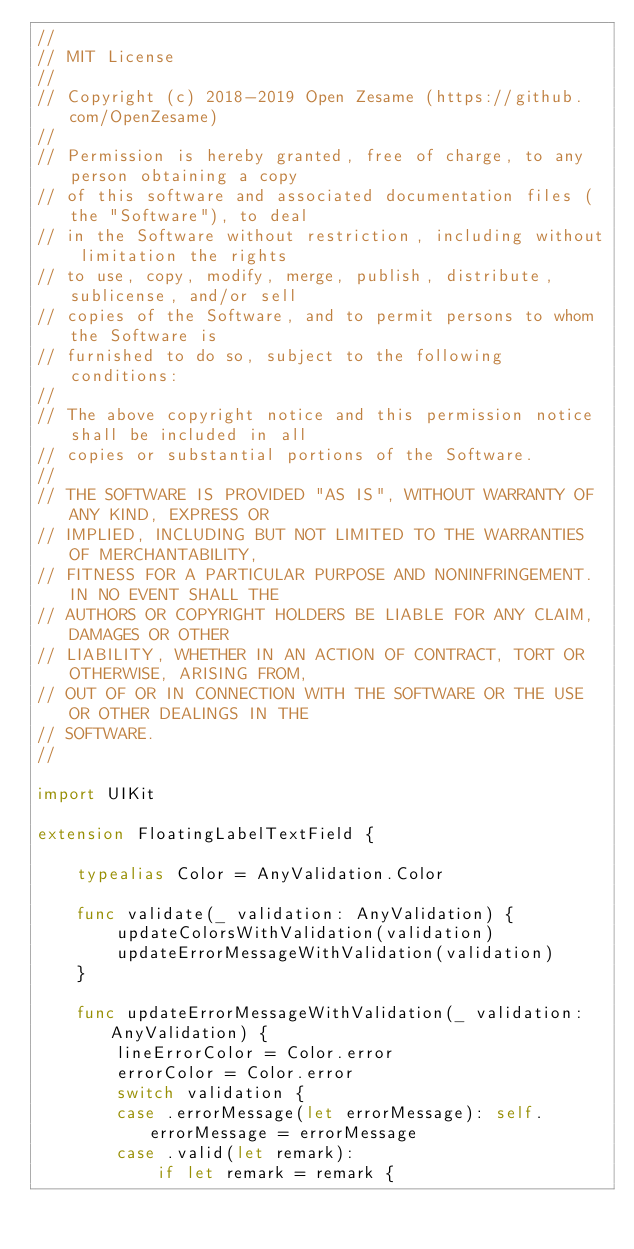<code> <loc_0><loc_0><loc_500><loc_500><_Swift_>// 
// MIT License
//
// Copyright (c) 2018-2019 Open Zesame (https://github.com/OpenZesame)
// 
// Permission is hereby granted, free of charge, to any person obtaining a copy
// of this software and associated documentation files (the "Software"), to deal
// in the Software without restriction, including without limitation the rights
// to use, copy, modify, merge, publish, distribute, sublicense, and/or sell
// copies of the Software, and to permit persons to whom the Software is
// furnished to do so, subject to the following conditions:
// 
// The above copyright notice and this permission notice shall be included in all
// copies or substantial portions of the Software.
// 
// THE SOFTWARE IS PROVIDED "AS IS", WITHOUT WARRANTY OF ANY KIND, EXPRESS OR
// IMPLIED, INCLUDING BUT NOT LIMITED TO THE WARRANTIES OF MERCHANTABILITY,
// FITNESS FOR A PARTICULAR PURPOSE AND NONINFRINGEMENT. IN NO EVENT SHALL THE
// AUTHORS OR COPYRIGHT HOLDERS BE LIABLE FOR ANY CLAIM, DAMAGES OR OTHER
// LIABILITY, WHETHER IN AN ACTION OF CONTRACT, TORT OR OTHERWISE, ARISING FROM,
// OUT OF OR IN CONNECTION WITH THE SOFTWARE OR THE USE OR OTHER DEALINGS IN THE
// SOFTWARE.
//

import UIKit

extension FloatingLabelTextField {
    
    typealias Color = AnyValidation.Color

    func validate(_ validation: AnyValidation) {
        updateColorsWithValidation(validation)
        updateErrorMessageWithValidation(validation)
    }

    func updateErrorMessageWithValidation(_ validation: AnyValidation) {
        lineErrorColor = Color.error
        errorColor = Color.error
        switch validation {
        case .errorMessage(let errorMessage): self.errorMessage = errorMessage
        case .valid(let remark):
            if let remark = remark {</code> 